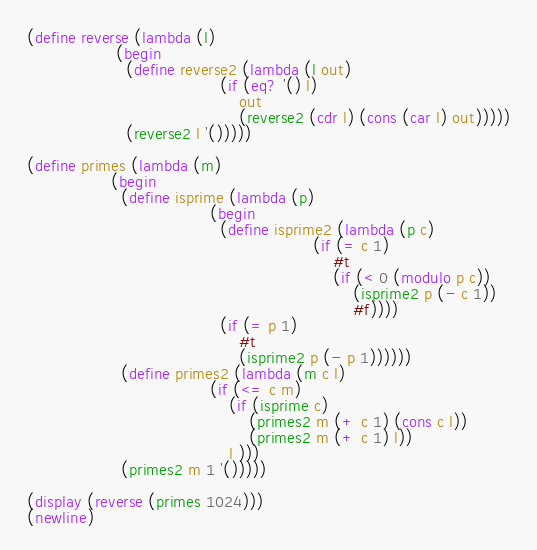<code> <loc_0><loc_0><loc_500><loc_500><_Scheme_>(define reverse (lambda (l)
                  (begin
                    (define reverse2 (lambda (l out)
                                       (if (eq? '() l)
                                           out
                                           (reverse2 (cdr l) (cons (car l) out)))))
                    (reverse2 l '()))))

(define primes (lambda (m)
                 (begin
                   (define isprime (lambda (p)
                                     (begin
                                       (define isprime2 (lambda (p c)
                                                          (if (= c 1)
                                                              #t
                                                              (if (< 0 (modulo p c))
                                                                  (isprime2 p (- c 1))
                                                                  #f))))
                                       (if (= p 1)
                                           #t
                                           (isprime2 p (- p 1))))))
                   (define primes2 (lambda (m c l)
                                     (if (<= c m)
                                         (if (isprime c)
                                             (primes2 m (+ c 1) (cons c l))
                                             (primes2 m (+ c 1) l))
                                         l )))
                   (primes2 m 1 '()))))

(display (reverse (primes 1024)))
(newline)

</code> 